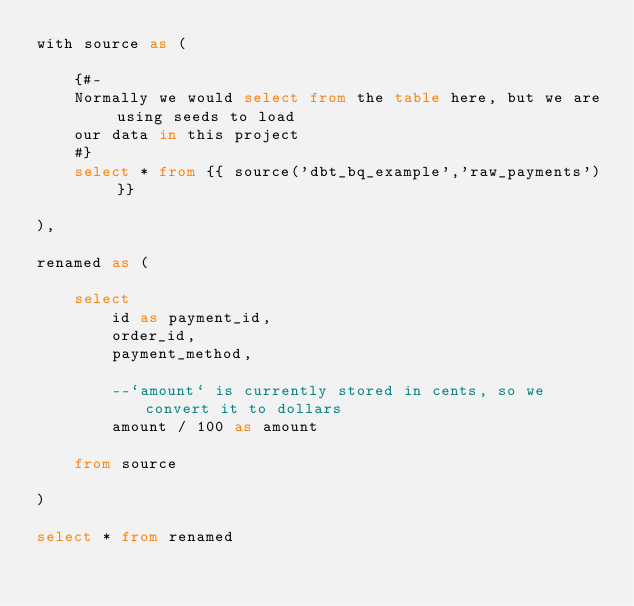Convert code to text. <code><loc_0><loc_0><loc_500><loc_500><_SQL_>with source as (
    
    {#-
    Normally we would select from the table here, but we are using seeds to load
    our data in this project
    #}
    select * from {{ source('dbt_bq_example','raw_payments') }}

),

renamed as (

    select
        id as payment_id,
        order_id,
        payment_method,

        --`amount` is currently stored in cents, so we convert it to dollars
        amount / 100 as amount

    from source

)

select * from renamed
</code> 